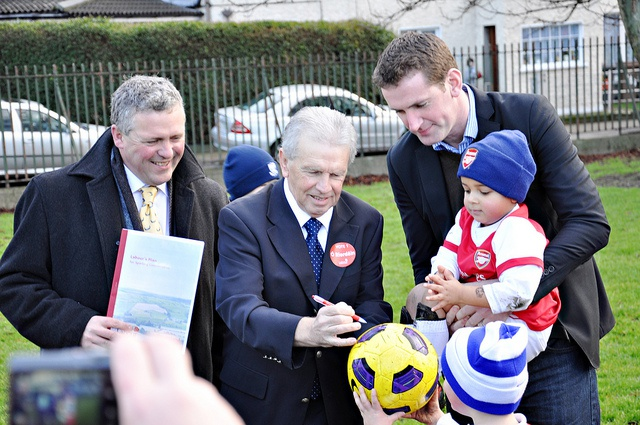Describe the objects in this image and their specific colors. I can see people in gray, black, navy, and lightgray tones, people in gray, black, navy, and darkgray tones, people in gray, black, lightgray, and darkgray tones, people in gray, white, darkblue, lightpink, and brown tones, and people in gray, lavender, darkblue, blue, and darkgray tones in this image. 